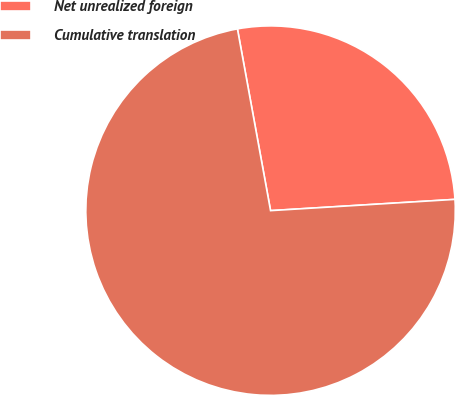<chart> <loc_0><loc_0><loc_500><loc_500><pie_chart><fcel>Net unrealized foreign<fcel>Cumulative translation<nl><fcel>26.9%<fcel>73.1%<nl></chart> 